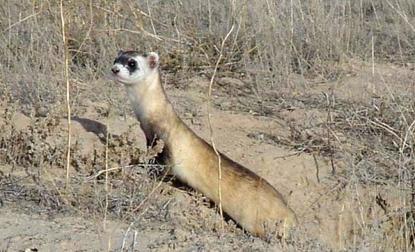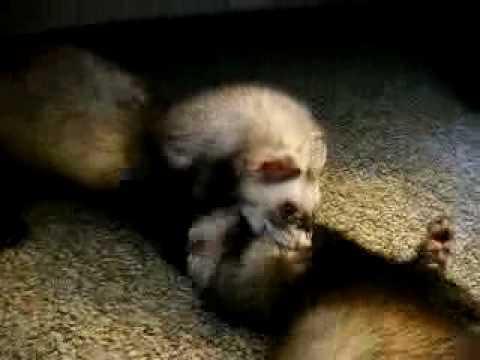The first image is the image on the left, the second image is the image on the right. For the images shown, is this caption "One image shows a single ferret with its head raised and gazing leftward." true? Answer yes or no. Yes. The first image is the image on the left, the second image is the image on the right. Analyze the images presented: Is the assertion "The right image contains exactly one ferret curled up on the floor." valid? Answer yes or no. No. 